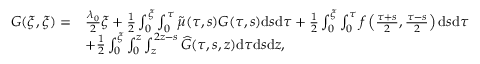Convert formula to latex. <formula><loc_0><loc_0><loc_500><loc_500>\begin{array} { r l } { G ( \xi , \xi ) = } & { { \frac { \lambda _ { 0 } } { 2 } } \xi + { { \frac { 1 } { 2 } } \int _ { 0 } ^ { \xi } \int _ { 0 } ^ { \tau } \widetilde { \mu } ( \tau , s ) G ( \tau , s ) d s d \tau } + \frac { 1 } { 2 } \int _ { 0 } ^ { \xi } \int _ { 0 } ^ { \tau } f \left ( \frac { \tau + s } { 2 } , \frac { \tau - s } { 2 } \right ) d s d \tau } \\ & { + \frac { 1 } { 2 } \int _ { 0 } ^ { \xi } \int _ { 0 } ^ { z } \int _ { z } ^ { 2 z - s } \widehat { G } ( \tau , s , z ) d \tau d s d z , } \end{array}</formula> 